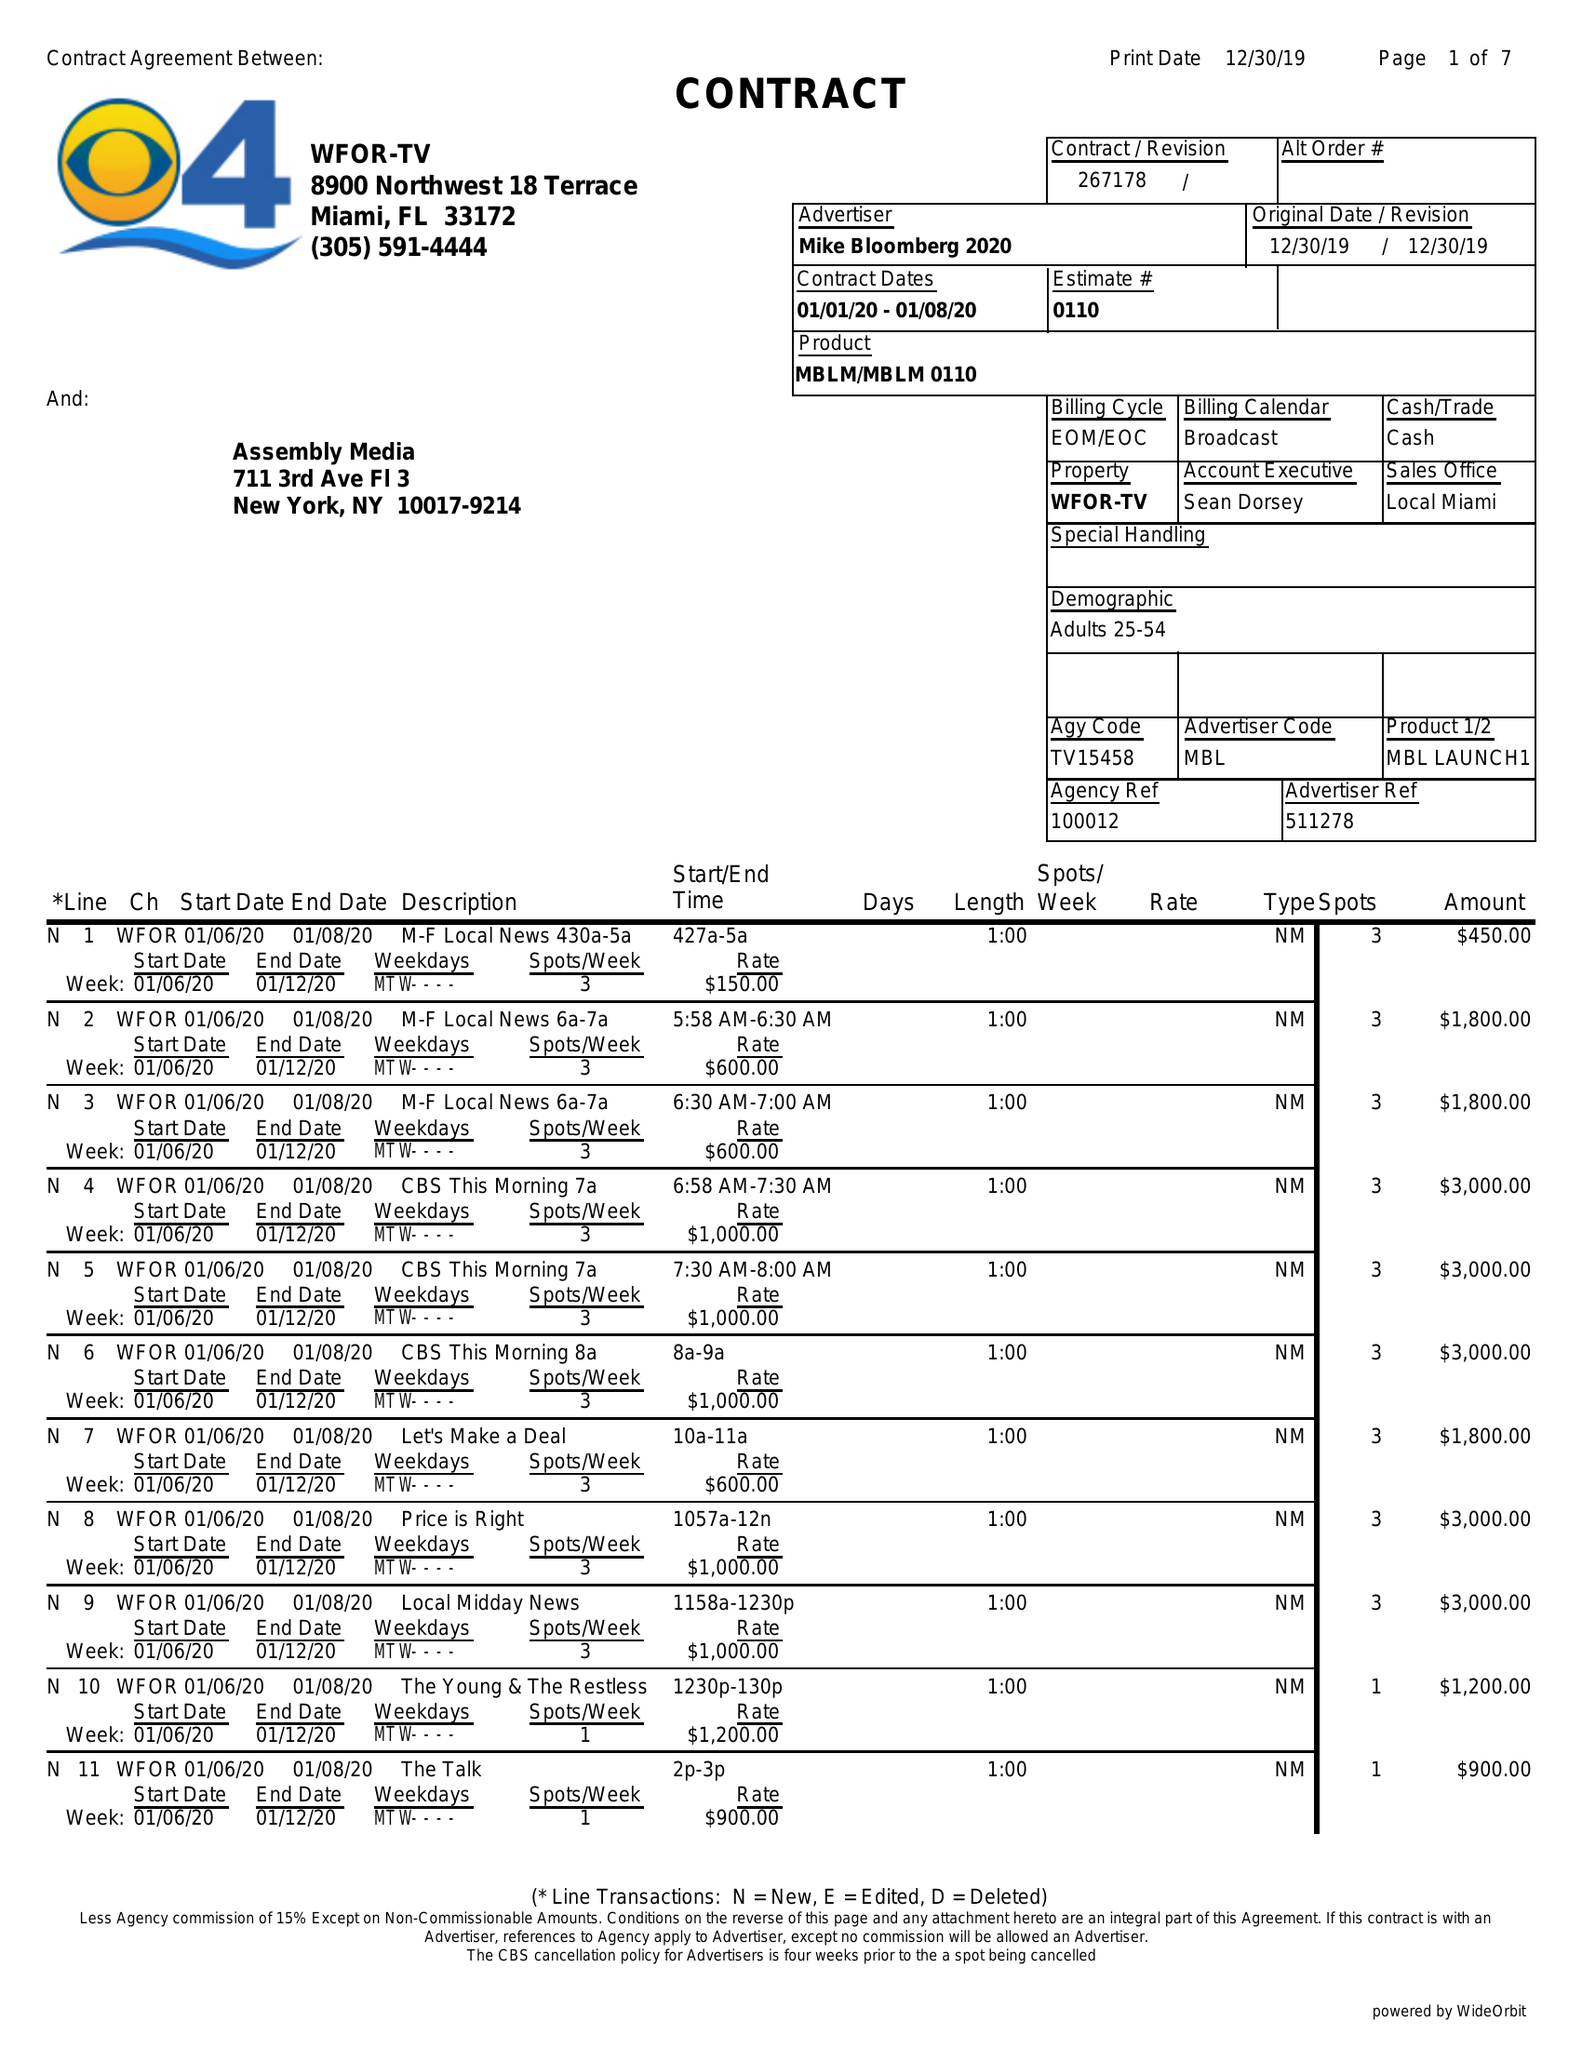What is the value for the advertiser?
Answer the question using a single word or phrase. MIKE BLOOMBERG 2020 